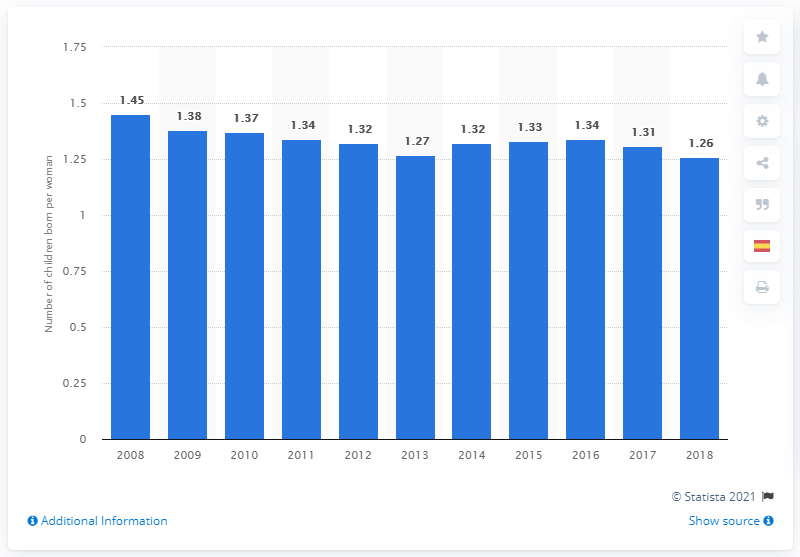Outline some significant characteristics in this image. The fertility rate in Spain in 2018 was 1.26. 